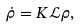Convert formula to latex. <formula><loc_0><loc_0><loc_500><loc_500>\dot { \rho } = K \mathcal { L } \rho ,</formula> 